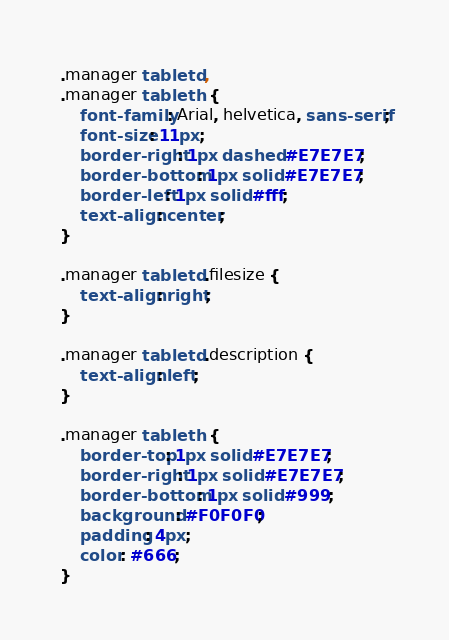<code> <loc_0><loc_0><loc_500><loc_500><_CSS_>.manager table td,
.manager table th {
	font-family: Arial, helvetica, sans-serif;
	font-size: 11px;
	border-right: 1px dashed #E7E7E7;
	border-bottom: 1px solid #E7E7E7;
	border-left: 1px solid #fff;
	text-align: center;
}

.manager table td.filesize {
	text-align: right;
}

.manager table td.description {
	text-align: left;
}

.manager table th {
	border-top: 1px solid #E7E7E7;
	border-right: 1px solid #E7E7E7;
	border-bottom: 1px solid #999;
	background: #F0F0F0;
	padding: 4px;
	color: #666;
}
</code> 